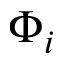<formula> <loc_0><loc_0><loc_500><loc_500>\Phi _ { i }</formula> 